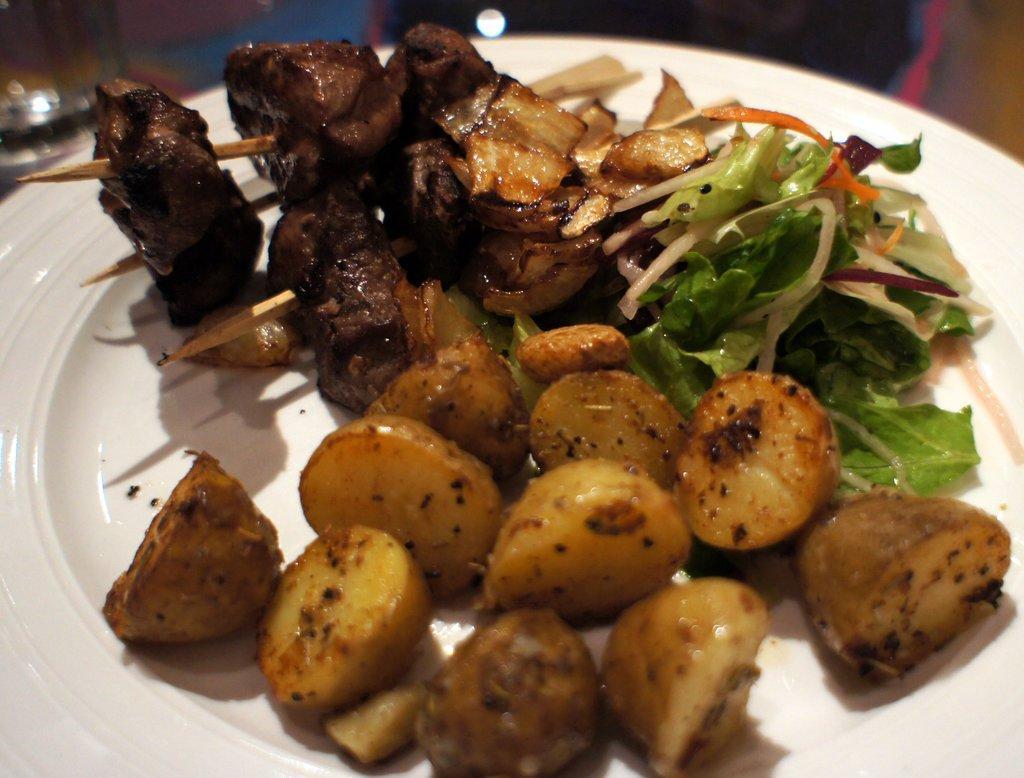Can you describe this image briefly? In this picture we can see food in the plate. 